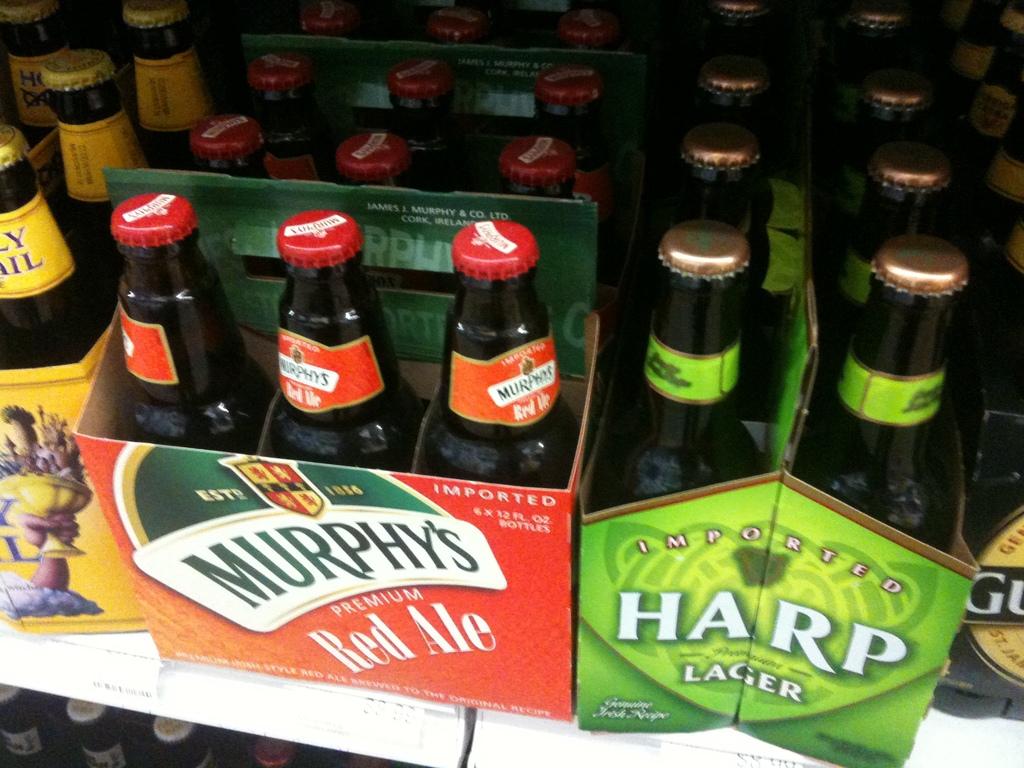Which beer has the green package?
Offer a very short reply. Harp. What kind of beer is in the orange carton?
Offer a terse response. Murphy's red ale. 